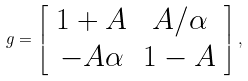Convert formula to latex. <formula><loc_0><loc_0><loc_500><loc_500>g = \left [ \begin{array} { c c } 1 + A & A / \alpha \\ - A \alpha & 1 - A \end{array} \right ] ,</formula> 